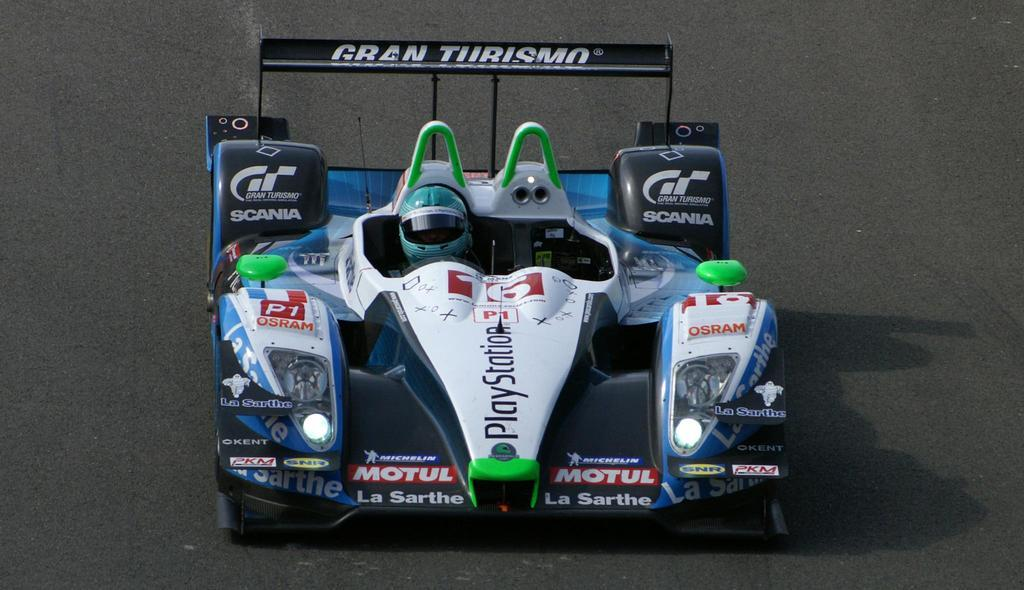What is the main subject of the image? The main subject of the image is a sports car. Where is the sports car located in the image? The sports car is in the center of the image. Is there any text or writing on the sports car? Yes, there is text or writing on the sports car. What type of wine is being served in the image? There is no wine present in the image; it features a sports car with text or writing on it. 